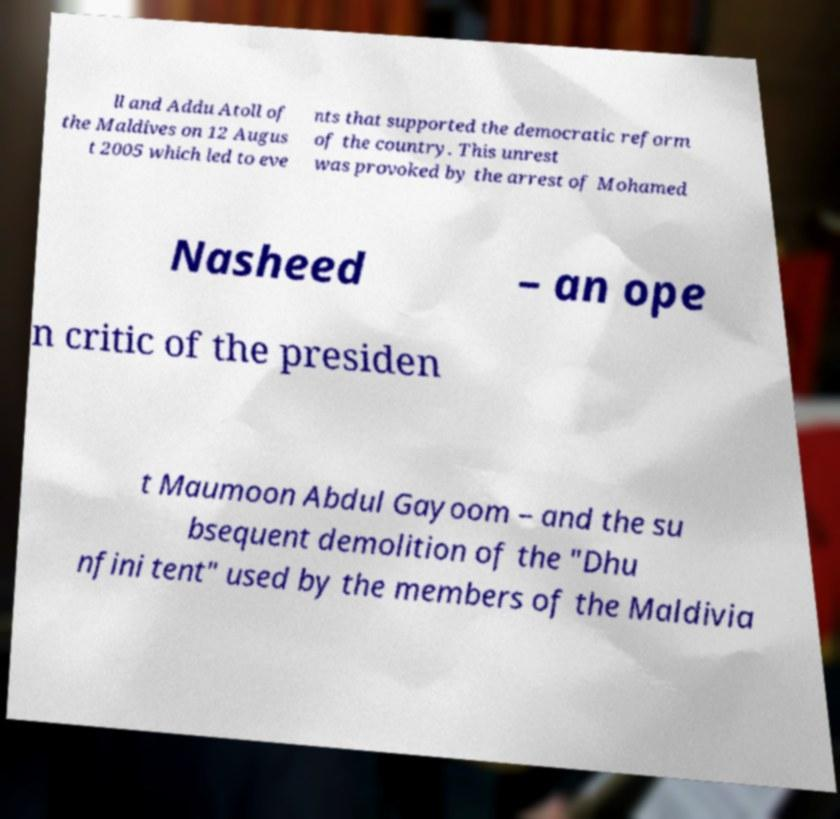Can you accurately transcribe the text from the provided image for me? ll and Addu Atoll of the Maldives on 12 Augus t 2005 which led to eve nts that supported the democratic reform of the country. This unrest was provoked by the arrest of Mohamed Nasheed – an ope n critic of the presiden t Maumoon Abdul Gayoom – and the su bsequent demolition of the "Dhu nfini tent" used by the members of the Maldivia 